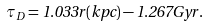Convert formula to latex. <formula><loc_0><loc_0><loc_500><loc_500>\tau _ { D } = 1 . 0 3 3 r ( k p c ) - 1 . 2 6 7 G y r .</formula> 